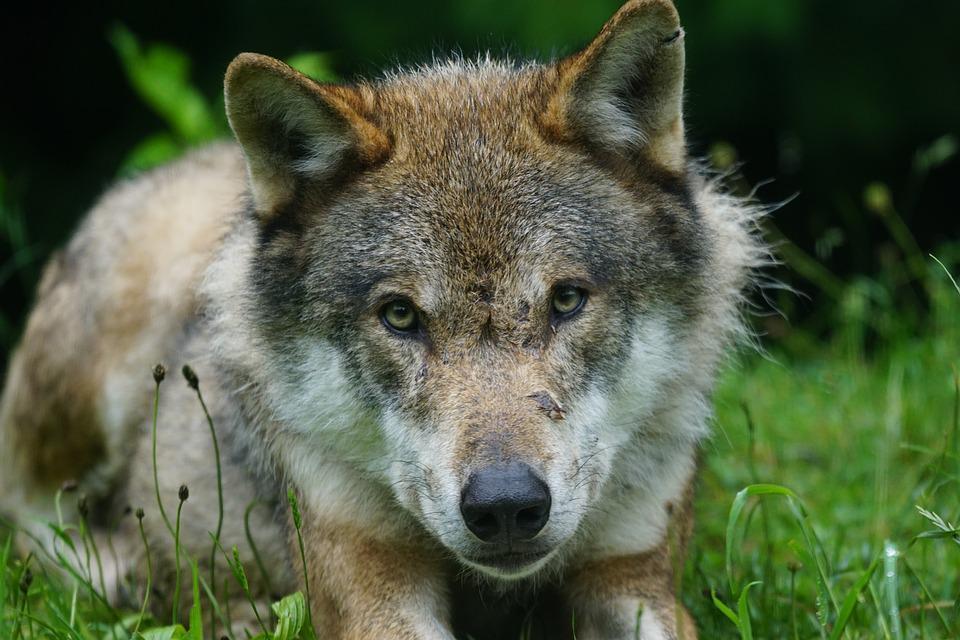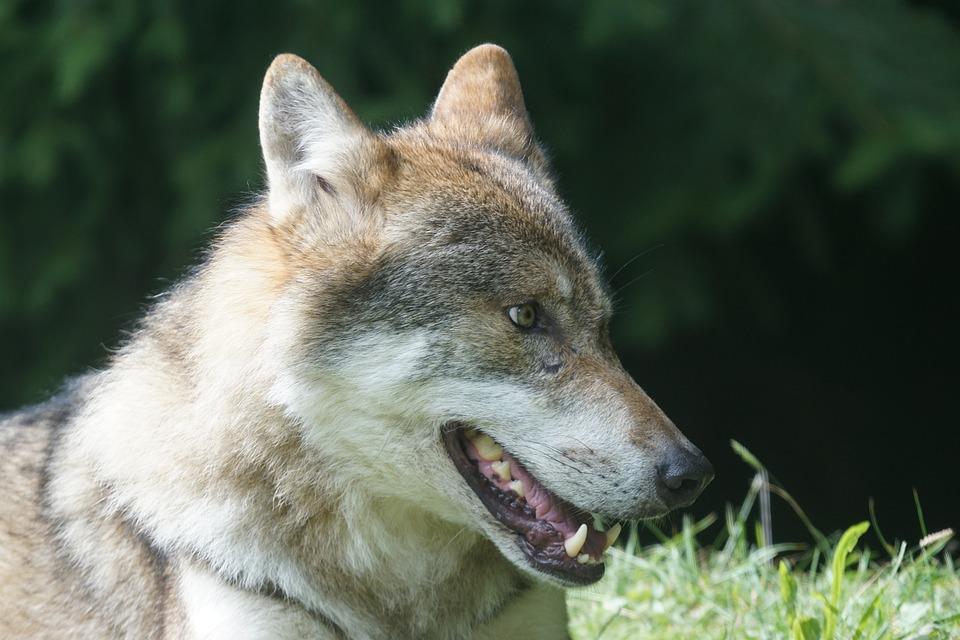The first image is the image on the left, the second image is the image on the right. Assess this claim about the two images: "A wolfs tongue is visible.". Correct or not? Answer yes or no. Yes. The first image is the image on the left, the second image is the image on the right. Examine the images to the left and right. Is the description "At least one image shows a wold standing on all fours in a nonsnowy setting." accurate? Answer yes or no. No. 